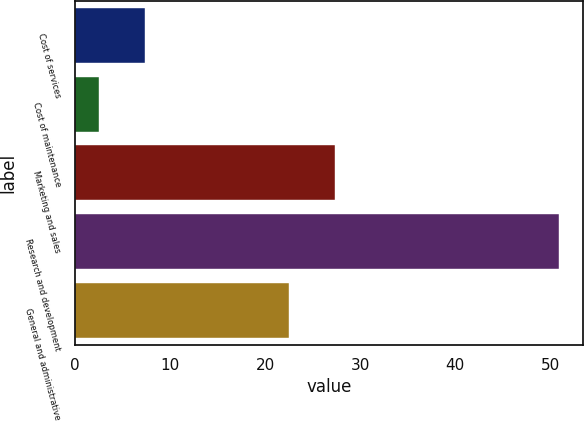Convert chart. <chart><loc_0><loc_0><loc_500><loc_500><bar_chart><fcel>Cost of services<fcel>Cost of maintenance<fcel>Marketing and sales<fcel>Research and development<fcel>General and administrative<nl><fcel>7.34<fcel>2.5<fcel>27.34<fcel>50.9<fcel>22.5<nl></chart> 